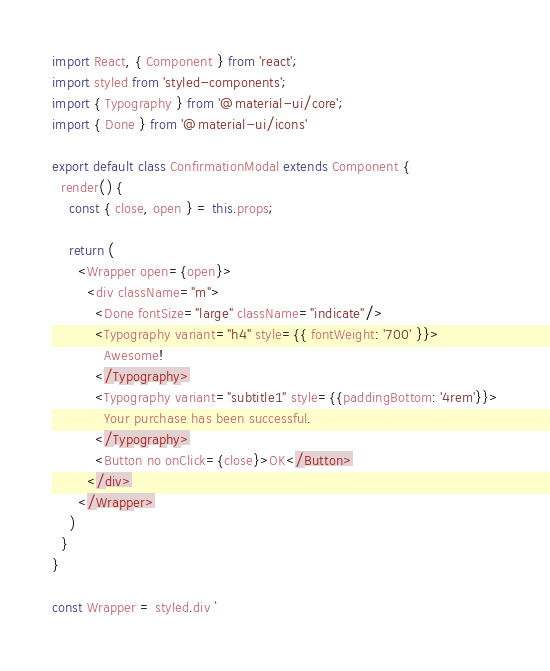Convert code to text. <code><loc_0><loc_0><loc_500><loc_500><_JavaScript_>import React, { Component } from 'react';
import styled from 'styled-components';
import { Typography } from '@material-ui/core';
import { Done } from '@material-ui/icons'

export default class ConfirmationModal extends Component {
  render() {
    const { close, open } = this.props;

    return (
      <Wrapper open={open}>
        <div className="m">
          <Done fontSize="large" className="indicate"/>
          <Typography variant="h4" style={{ fontWeight: '700' }}>
            Awesome!
          </Typography>
          <Typography variant="subtitle1" style={{paddingBottom: '4rem'}}>
            Your purchase has been successful.
          </Typography>
          <Button no onClick={close}>OK</Button>
        </div>
      </Wrapper>
    )
  }
}

const Wrapper = styled.div `</code> 